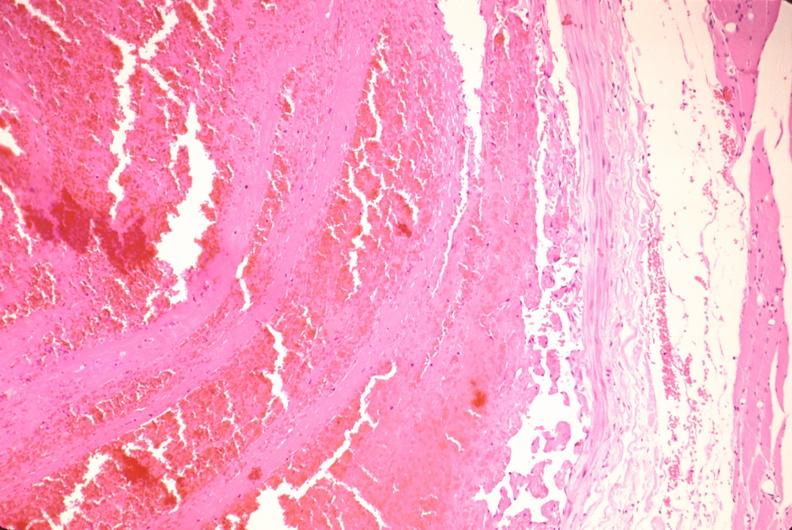does this image show thrombus in leg vein with early organization?
Answer the question using a single word or phrase. Yes 